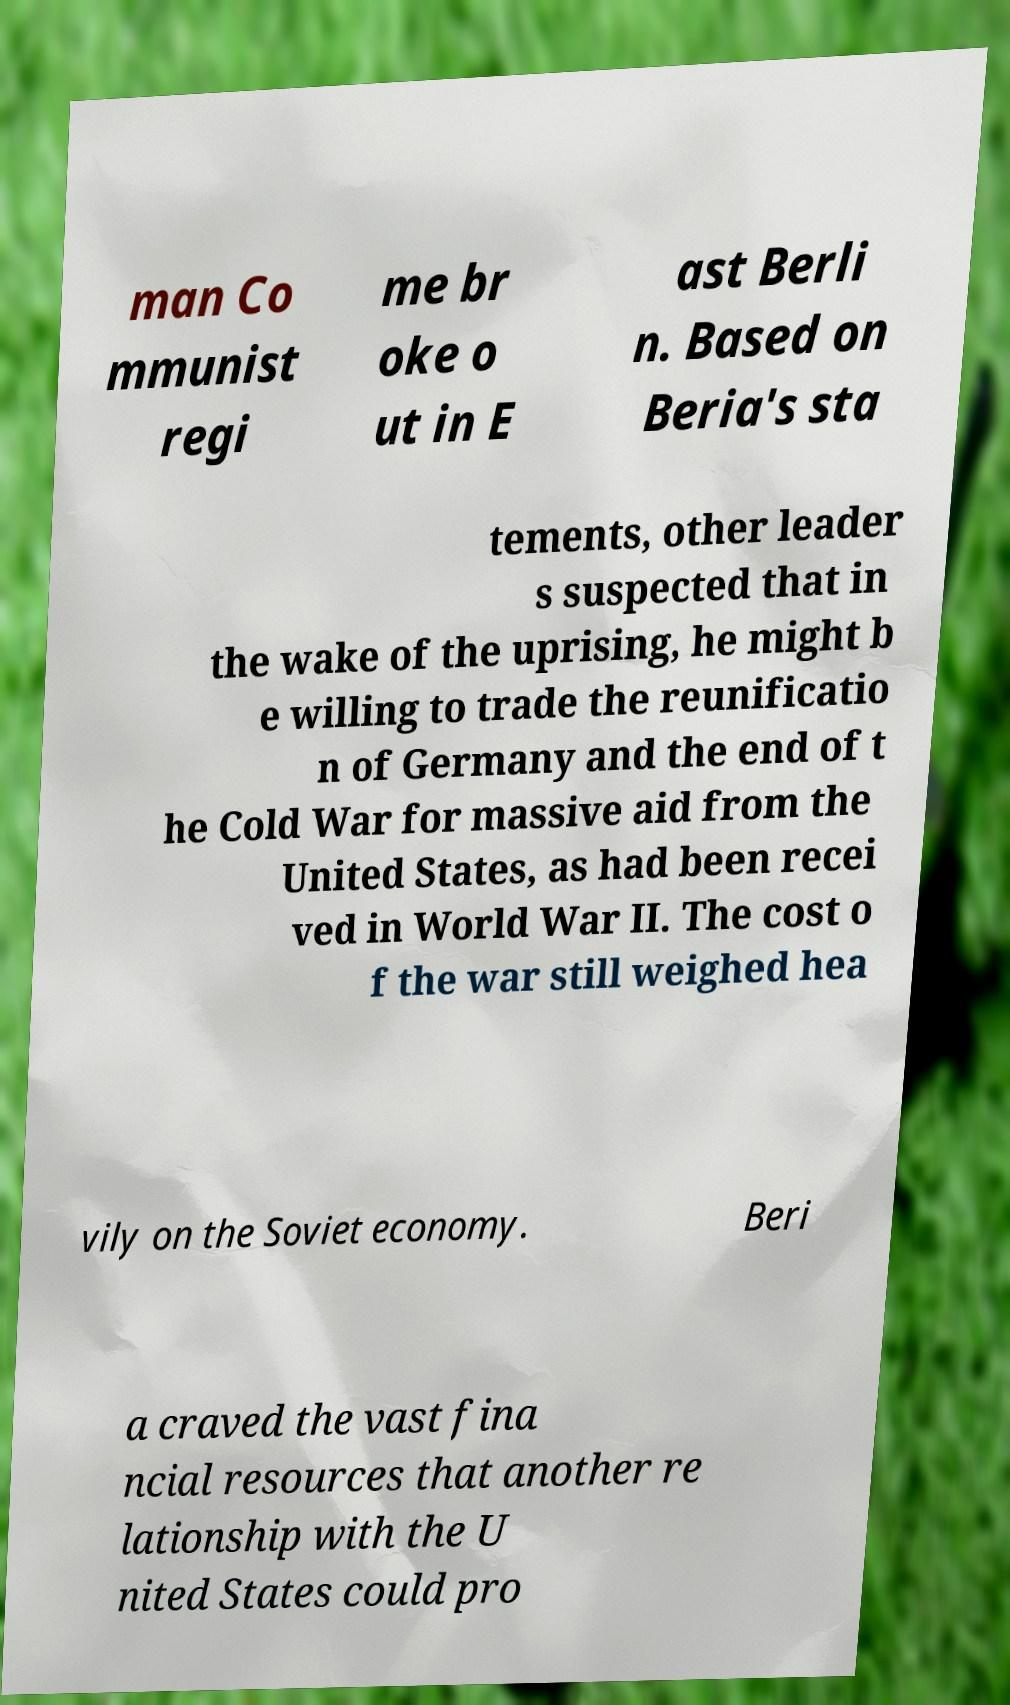What messages or text are displayed in this image? I need them in a readable, typed format. man Co mmunist regi me br oke o ut in E ast Berli n. Based on Beria's sta tements, other leader s suspected that in the wake of the uprising, he might b e willing to trade the reunificatio n of Germany and the end of t he Cold War for massive aid from the United States, as had been recei ved in World War II. The cost o f the war still weighed hea vily on the Soviet economy. Beri a craved the vast fina ncial resources that another re lationship with the U nited States could pro 